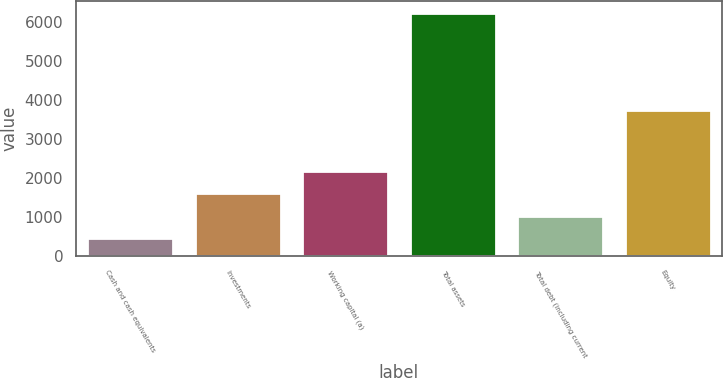Convert chart. <chart><loc_0><loc_0><loc_500><loc_500><bar_chart><fcel>Cash and cash equivalents<fcel>Investments<fcel>Working capital (a)<fcel>Total assets<fcel>Total debt (including current<fcel>Equity<nl><fcel>456.3<fcel>1607.66<fcel>2183.34<fcel>6213.1<fcel>1031.98<fcel>3743.5<nl></chart> 